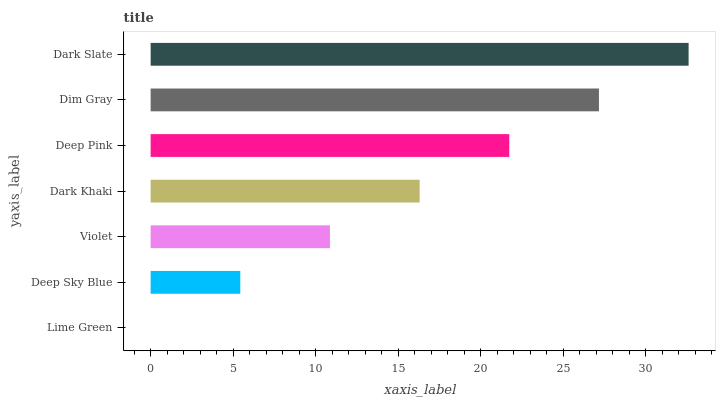Is Lime Green the minimum?
Answer yes or no. Yes. Is Dark Slate the maximum?
Answer yes or no. Yes. Is Deep Sky Blue the minimum?
Answer yes or no. No. Is Deep Sky Blue the maximum?
Answer yes or no. No. Is Deep Sky Blue greater than Lime Green?
Answer yes or no. Yes. Is Lime Green less than Deep Sky Blue?
Answer yes or no. Yes. Is Lime Green greater than Deep Sky Blue?
Answer yes or no. No. Is Deep Sky Blue less than Lime Green?
Answer yes or no. No. Is Dark Khaki the high median?
Answer yes or no. Yes. Is Dark Khaki the low median?
Answer yes or no. Yes. Is Lime Green the high median?
Answer yes or no. No. Is Dim Gray the low median?
Answer yes or no. No. 